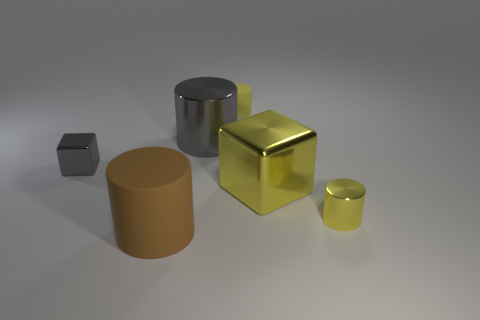Can you describe the different textures visible in the scene? Certainly. In the image, there are several objects with differing textures. The large yellow block and the small yellow cylinder have a smooth, metallic gloss which reflects light, giving them a shiny appearance. In contrast, the large brown cylinder appears to have a matte finish with no shine, suggesting a rougher or more absorbent surface. 